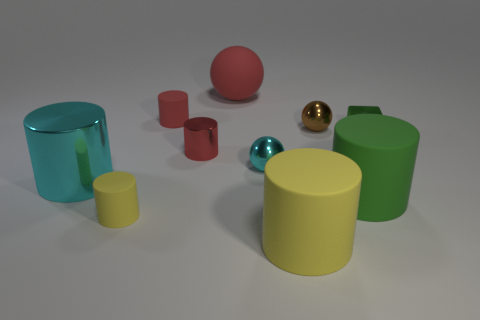The other metal thing that is the same shape as the tiny brown thing is what color?
Ensure brevity in your answer.  Cyan. Does the tiny rubber cylinder that is behind the big cyan cylinder have the same color as the rubber sphere?
Give a very brief answer. Yes. What number of small purple shiny things are there?
Provide a succinct answer. 0. Are the yellow thing to the right of the small yellow rubber thing and the large green cylinder made of the same material?
Give a very brief answer. Yes. How many large matte things are to the right of the tiny ball that is on the right side of the yellow cylinder right of the tiny red matte thing?
Provide a succinct answer. 1. What is the size of the cyan cylinder?
Your answer should be very brief. Large. Is the big sphere the same color as the small shiny cylinder?
Offer a very short reply. Yes. There is a green object that is in front of the cyan metallic cylinder; what is its size?
Your answer should be compact. Large. Does the small rubber thing that is in front of the tiny green metallic thing have the same color as the cylinder in front of the tiny yellow object?
Your answer should be very brief. Yes. What number of other objects are there of the same shape as the small cyan object?
Your answer should be compact. 2. 